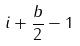Convert formula to latex. <formula><loc_0><loc_0><loc_500><loc_500>i + \frac { b } { 2 } - 1</formula> 